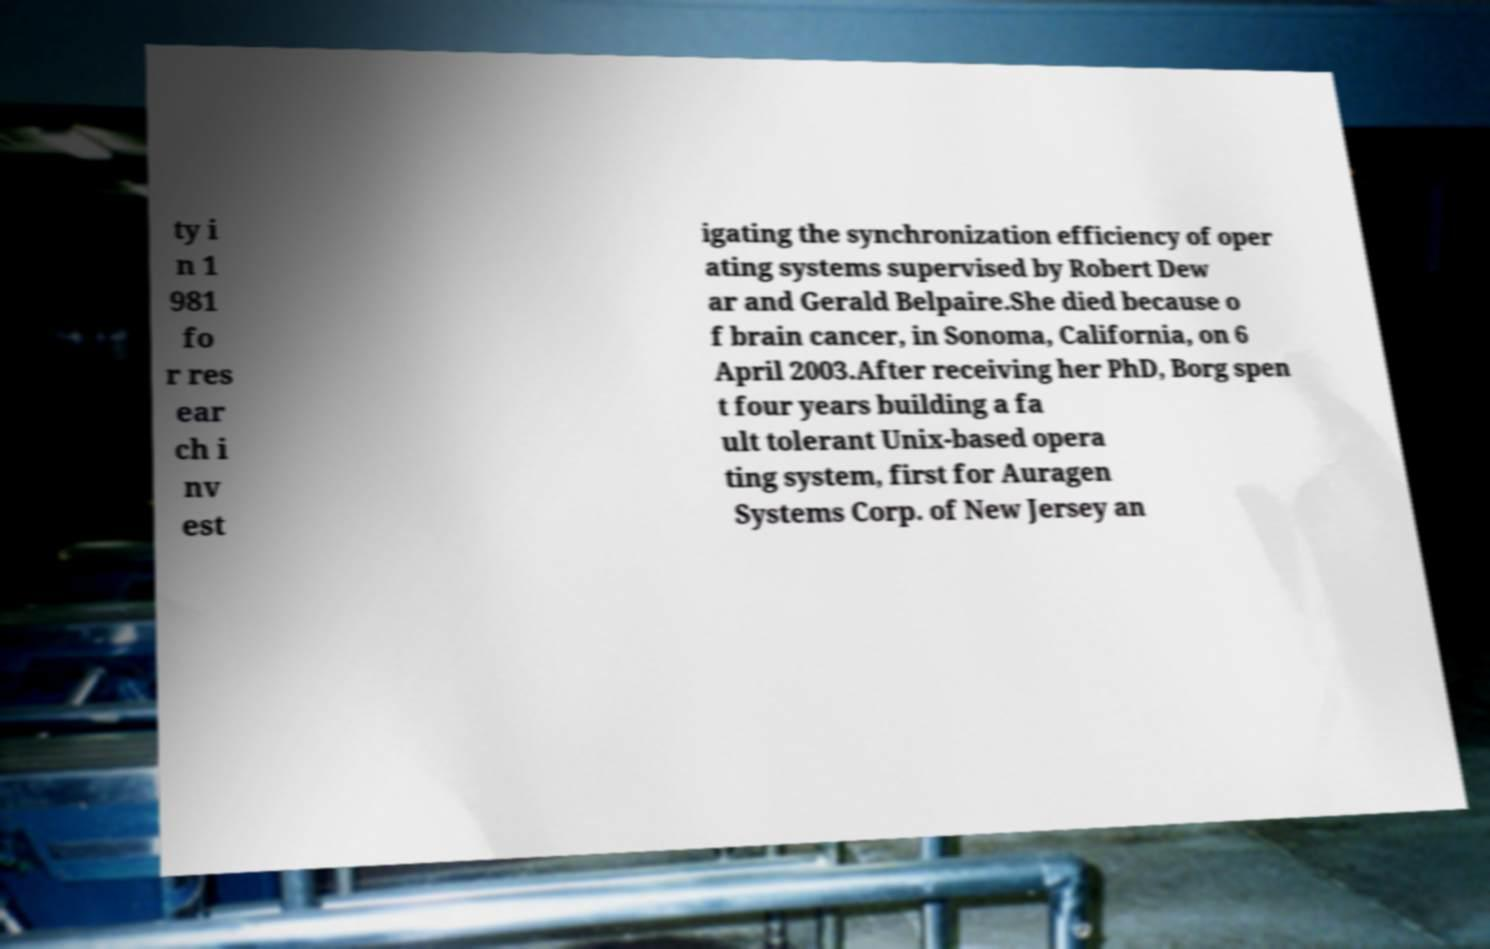For documentation purposes, I need the text within this image transcribed. Could you provide that? ty i n 1 981 fo r res ear ch i nv est igating the synchronization efficiency of oper ating systems supervised by Robert Dew ar and Gerald Belpaire.She died because o f brain cancer, in Sonoma, California, on 6 April 2003.After receiving her PhD, Borg spen t four years building a fa ult tolerant Unix-based opera ting system, first for Auragen Systems Corp. of New Jersey an 